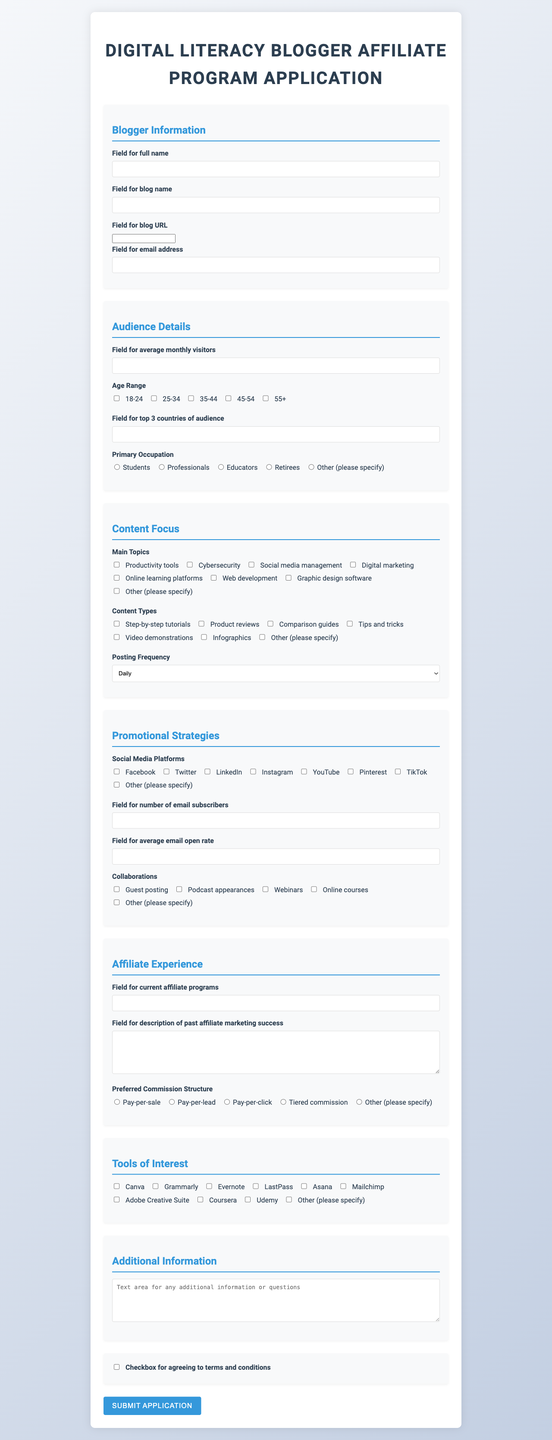what is the title of the form? The title of the form is clearly stated at the top of the document.
Answer: Digital Literacy Blogger Affiliate Program Application how many age ranges are listed? The document contains a specific section detailing the audience's demographics, which includes several options for age ranges.
Answer: 5 which social media platform is included in the promotional strategies? The promotional strategies section lists various social media platforms that the blogger might use.
Answer: Facebook what is the frequency of posting options provided? The content focus section specifically offers a choice of posting frequencies for the blogger to select from.
Answer: Daily, 2-3 times per week, Weekly, Bi-weekly, Monthly how many tools of interest are listed? The document outlines a section dedicated to tools that the blogger may be interested in promoting.
Answer: 10 what type of input is provided for 'average open rate'? The form specifies the type of information requested regarding email marketing performance metrics in a particular field.
Answer: Field for average email open rate which option is given for primary occupation? The audience details section includes various suggestions for the primary occupation of the audience, indicating the types of people engaging with the blog.
Answer: Students what is the preferred commission structure category? The affiliate experience section outlines different types of commission structures that the blogger can choose from.
Answer: Pay-per-sale, Pay-per-lead, Pay-per-click, Tiered commission, Other (please specify) 